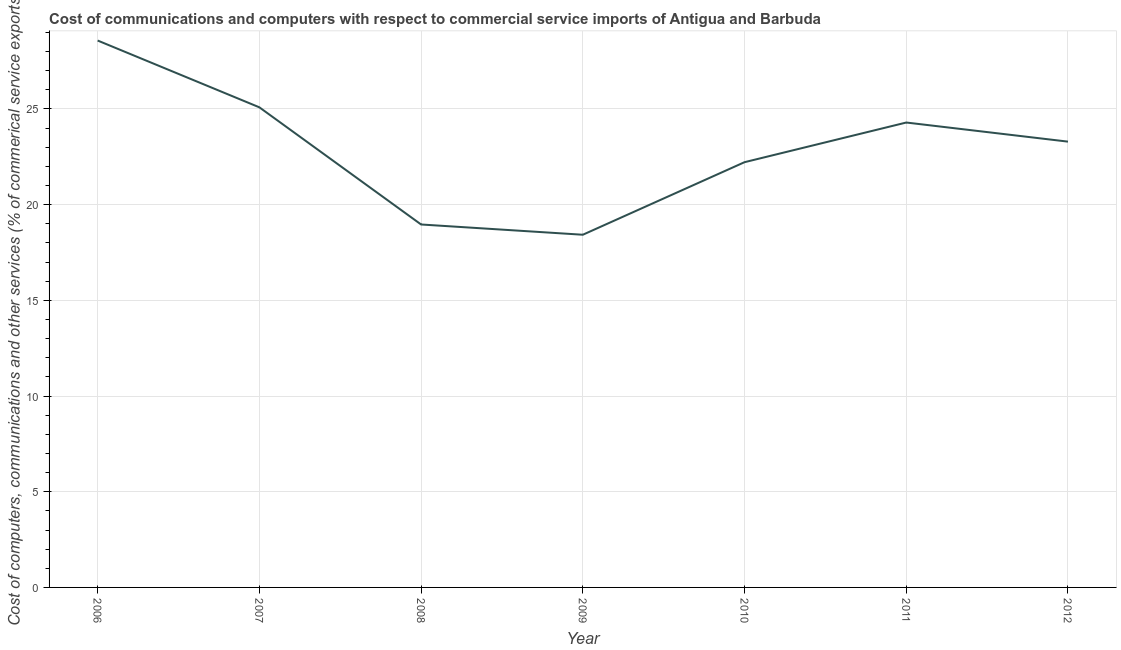What is the  computer and other services in 2006?
Provide a succinct answer. 28.57. Across all years, what is the maximum cost of communications?
Make the answer very short. 28.57. Across all years, what is the minimum cost of communications?
Your answer should be compact. 18.42. In which year was the cost of communications maximum?
Ensure brevity in your answer.  2006. In which year was the  computer and other services minimum?
Make the answer very short. 2009. What is the sum of the cost of communications?
Your response must be concise. 160.83. What is the difference between the  computer and other services in 2007 and 2011?
Keep it short and to the point. 0.79. What is the average cost of communications per year?
Offer a terse response. 22.98. What is the median cost of communications?
Offer a very short reply. 23.29. What is the ratio of the  computer and other services in 2009 to that in 2012?
Ensure brevity in your answer.  0.79. Is the cost of communications in 2006 less than that in 2010?
Your answer should be very brief. No. Is the difference between the cost of communications in 2007 and 2008 greater than the difference between any two years?
Keep it short and to the point. No. What is the difference between the highest and the second highest cost of communications?
Your response must be concise. 3.49. Is the sum of the  computer and other services in 2006 and 2010 greater than the maximum  computer and other services across all years?
Provide a succinct answer. Yes. What is the difference between the highest and the lowest cost of communications?
Offer a terse response. 10.15. In how many years, is the  computer and other services greater than the average  computer and other services taken over all years?
Keep it short and to the point. 4. How many years are there in the graph?
Your response must be concise. 7. Are the values on the major ticks of Y-axis written in scientific E-notation?
Your response must be concise. No. Does the graph contain any zero values?
Offer a terse response. No. Does the graph contain grids?
Provide a short and direct response. Yes. What is the title of the graph?
Give a very brief answer. Cost of communications and computers with respect to commercial service imports of Antigua and Barbuda. What is the label or title of the Y-axis?
Provide a succinct answer. Cost of computers, communications and other services (% of commerical service exports). What is the Cost of computers, communications and other services (% of commerical service exports) of 2006?
Keep it short and to the point. 28.57. What is the Cost of computers, communications and other services (% of commerical service exports) in 2007?
Offer a terse response. 25.08. What is the Cost of computers, communications and other services (% of commerical service exports) in 2008?
Ensure brevity in your answer.  18.96. What is the Cost of computers, communications and other services (% of commerical service exports) in 2009?
Make the answer very short. 18.42. What is the Cost of computers, communications and other services (% of commerical service exports) of 2010?
Your answer should be very brief. 22.22. What is the Cost of computers, communications and other services (% of commerical service exports) of 2011?
Ensure brevity in your answer.  24.29. What is the Cost of computers, communications and other services (% of commerical service exports) of 2012?
Offer a very short reply. 23.29. What is the difference between the Cost of computers, communications and other services (% of commerical service exports) in 2006 and 2007?
Your answer should be compact. 3.49. What is the difference between the Cost of computers, communications and other services (% of commerical service exports) in 2006 and 2008?
Your response must be concise. 9.61. What is the difference between the Cost of computers, communications and other services (% of commerical service exports) in 2006 and 2009?
Your answer should be compact. 10.15. What is the difference between the Cost of computers, communications and other services (% of commerical service exports) in 2006 and 2010?
Your answer should be compact. 6.36. What is the difference between the Cost of computers, communications and other services (% of commerical service exports) in 2006 and 2011?
Provide a succinct answer. 4.28. What is the difference between the Cost of computers, communications and other services (% of commerical service exports) in 2006 and 2012?
Your response must be concise. 5.28. What is the difference between the Cost of computers, communications and other services (% of commerical service exports) in 2007 and 2008?
Your answer should be compact. 6.12. What is the difference between the Cost of computers, communications and other services (% of commerical service exports) in 2007 and 2009?
Give a very brief answer. 6.66. What is the difference between the Cost of computers, communications and other services (% of commerical service exports) in 2007 and 2010?
Offer a terse response. 2.87. What is the difference between the Cost of computers, communications and other services (% of commerical service exports) in 2007 and 2011?
Make the answer very short. 0.79. What is the difference between the Cost of computers, communications and other services (% of commerical service exports) in 2007 and 2012?
Your answer should be very brief. 1.79. What is the difference between the Cost of computers, communications and other services (% of commerical service exports) in 2008 and 2009?
Give a very brief answer. 0.54. What is the difference between the Cost of computers, communications and other services (% of commerical service exports) in 2008 and 2010?
Your response must be concise. -3.25. What is the difference between the Cost of computers, communications and other services (% of commerical service exports) in 2008 and 2011?
Provide a succinct answer. -5.33. What is the difference between the Cost of computers, communications and other services (% of commerical service exports) in 2008 and 2012?
Make the answer very short. -4.33. What is the difference between the Cost of computers, communications and other services (% of commerical service exports) in 2009 and 2010?
Provide a succinct answer. -3.79. What is the difference between the Cost of computers, communications and other services (% of commerical service exports) in 2009 and 2011?
Offer a terse response. -5.86. What is the difference between the Cost of computers, communications and other services (% of commerical service exports) in 2009 and 2012?
Offer a terse response. -4.86. What is the difference between the Cost of computers, communications and other services (% of commerical service exports) in 2010 and 2011?
Your answer should be very brief. -2.07. What is the difference between the Cost of computers, communications and other services (% of commerical service exports) in 2010 and 2012?
Provide a short and direct response. -1.07. What is the difference between the Cost of computers, communications and other services (% of commerical service exports) in 2011 and 2012?
Your answer should be compact. 1. What is the ratio of the Cost of computers, communications and other services (% of commerical service exports) in 2006 to that in 2007?
Provide a short and direct response. 1.14. What is the ratio of the Cost of computers, communications and other services (% of commerical service exports) in 2006 to that in 2008?
Your response must be concise. 1.51. What is the ratio of the Cost of computers, communications and other services (% of commerical service exports) in 2006 to that in 2009?
Offer a terse response. 1.55. What is the ratio of the Cost of computers, communications and other services (% of commerical service exports) in 2006 to that in 2010?
Ensure brevity in your answer.  1.29. What is the ratio of the Cost of computers, communications and other services (% of commerical service exports) in 2006 to that in 2011?
Your answer should be compact. 1.18. What is the ratio of the Cost of computers, communications and other services (% of commerical service exports) in 2006 to that in 2012?
Give a very brief answer. 1.23. What is the ratio of the Cost of computers, communications and other services (% of commerical service exports) in 2007 to that in 2008?
Your response must be concise. 1.32. What is the ratio of the Cost of computers, communications and other services (% of commerical service exports) in 2007 to that in 2009?
Give a very brief answer. 1.36. What is the ratio of the Cost of computers, communications and other services (% of commerical service exports) in 2007 to that in 2010?
Your response must be concise. 1.13. What is the ratio of the Cost of computers, communications and other services (% of commerical service exports) in 2007 to that in 2011?
Provide a short and direct response. 1.03. What is the ratio of the Cost of computers, communications and other services (% of commerical service exports) in 2007 to that in 2012?
Offer a terse response. 1.08. What is the ratio of the Cost of computers, communications and other services (% of commerical service exports) in 2008 to that in 2009?
Your response must be concise. 1.03. What is the ratio of the Cost of computers, communications and other services (% of commerical service exports) in 2008 to that in 2010?
Ensure brevity in your answer.  0.85. What is the ratio of the Cost of computers, communications and other services (% of commerical service exports) in 2008 to that in 2011?
Offer a terse response. 0.78. What is the ratio of the Cost of computers, communications and other services (% of commerical service exports) in 2008 to that in 2012?
Provide a short and direct response. 0.81. What is the ratio of the Cost of computers, communications and other services (% of commerical service exports) in 2009 to that in 2010?
Your response must be concise. 0.83. What is the ratio of the Cost of computers, communications and other services (% of commerical service exports) in 2009 to that in 2011?
Provide a succinct answer. 0.76. What is the ratio of the Cost of computers, communications and other services (% of commerical service exports) in 2009 to that in 2012?
Ensure brevity in your answer.  0.79. What is the ratio of the Cost of computers, communications and other services (% of commerical service exports) in 2010 to that in 2011?
Your answer should be very brief. 0.92. What is the ratio of the Cost of computers, communications and other services (% of commerical service exports) in 2010 to that in 2012?
Make the answer very short. 0.95. What is the ratio of the Cost of computers, communications and other services (% of commerical service exports) in 2011 to that in 2012?
Offer a terse response. 1.04. 